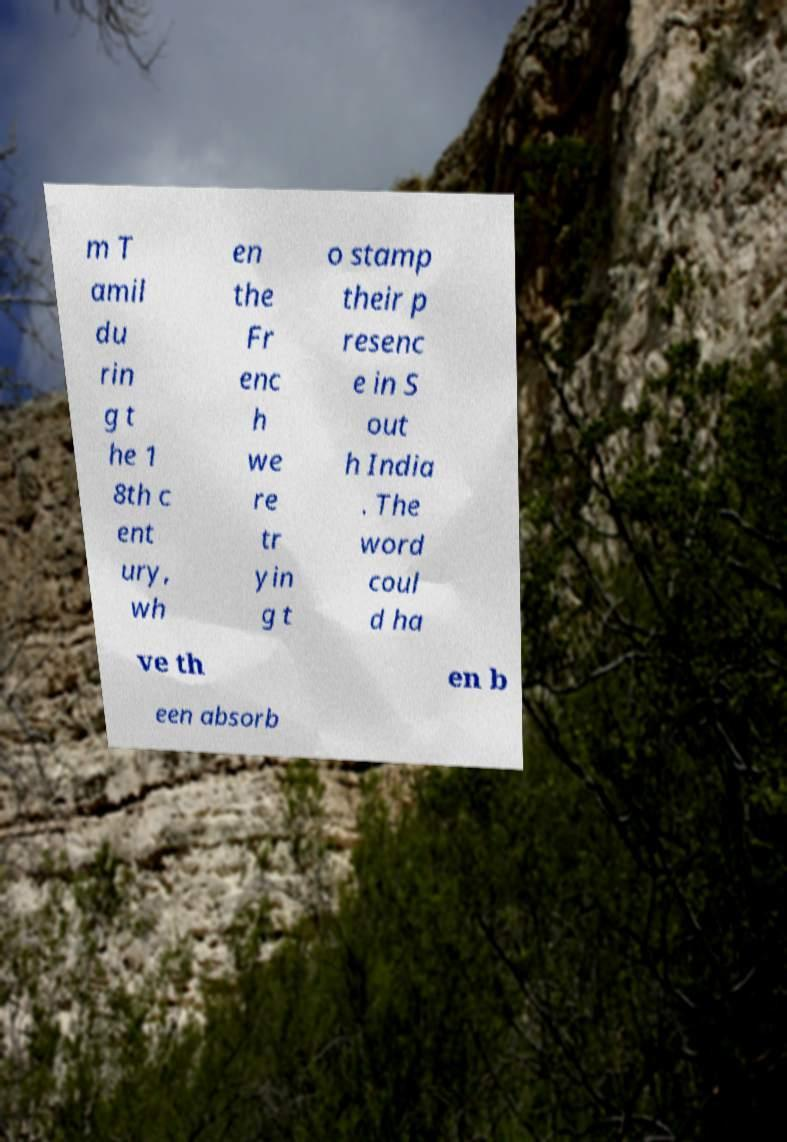Please identify and transcribe the text found in this image. m T amil du rin g t he 1 8th c ent ury, wh en the Fr enc h we re tr yin g t o stamp their p resenc e in S out h India . The word coul d ha ve th en b een absorb 